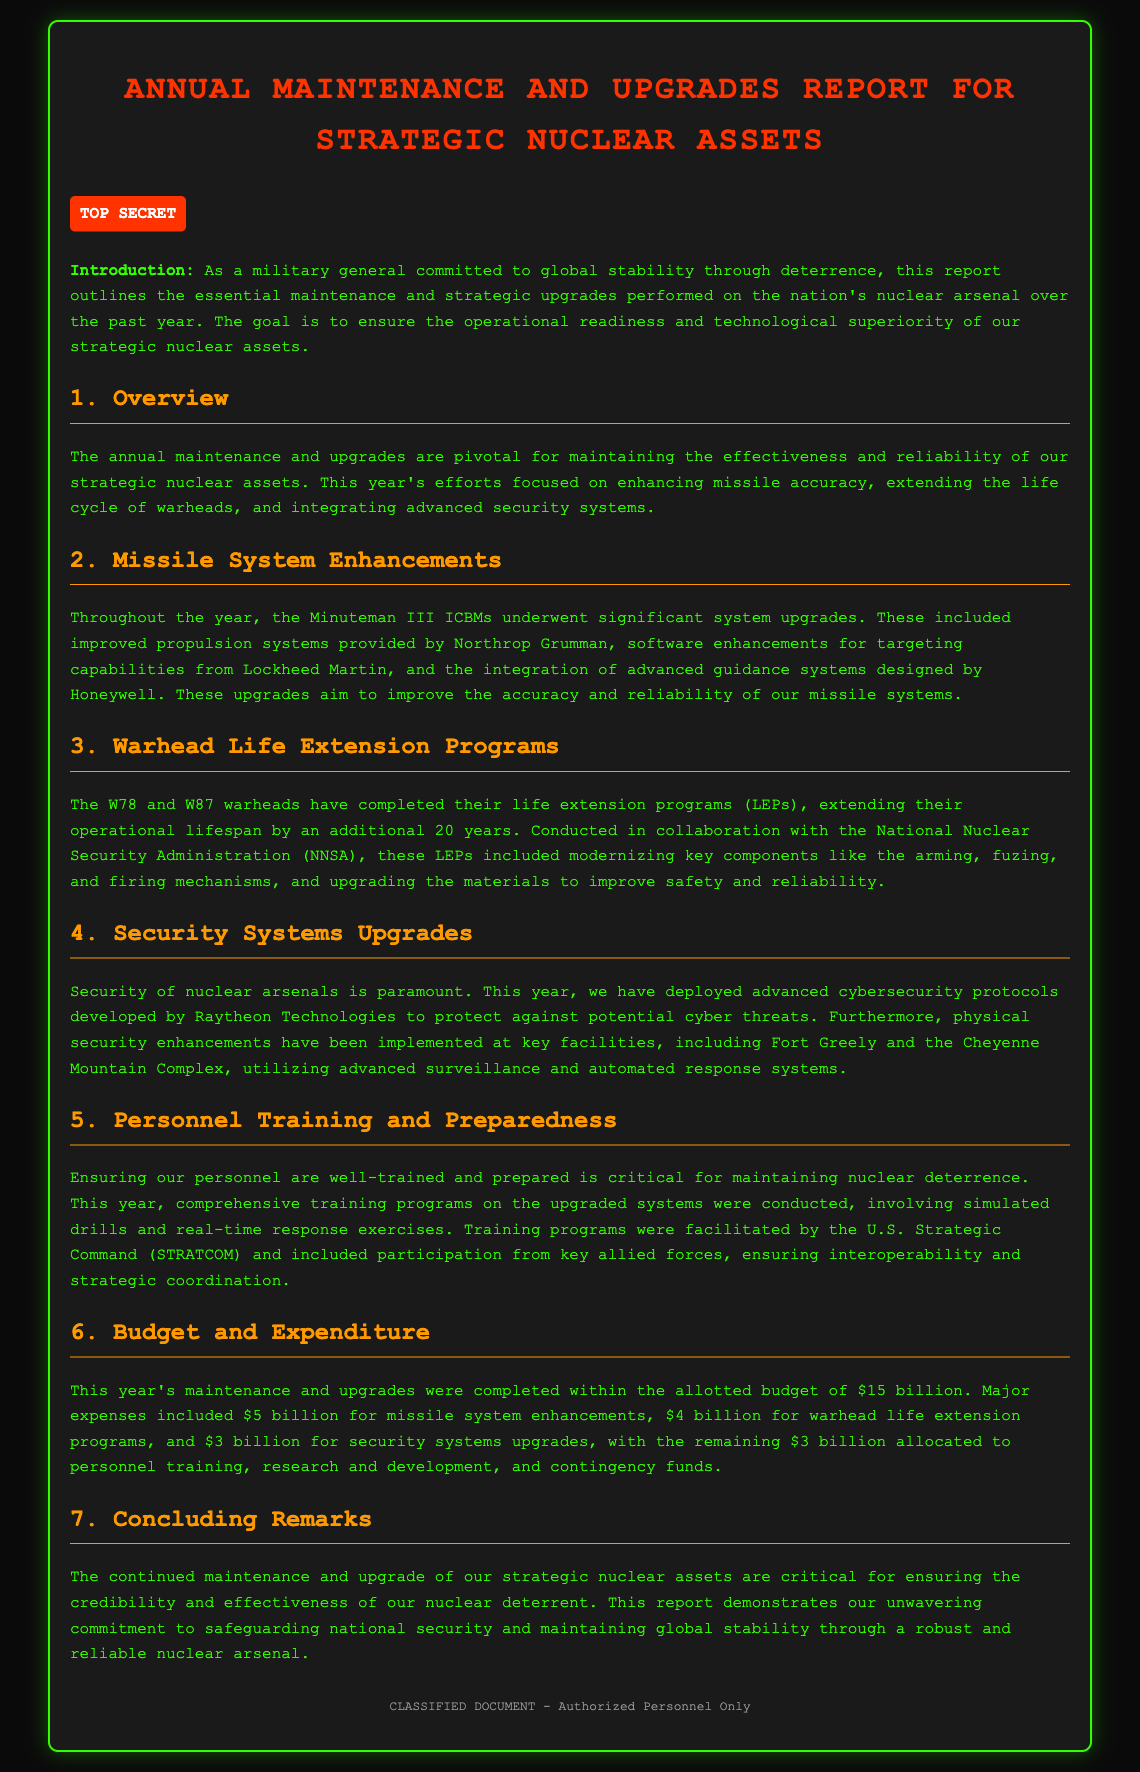What is the title of the report? The title of the report is clearly stated at the top of the document.
Answer: Annual Maintenance and Upgrades Report for Strategic Nuclear Assets What is the budget for this year's maintenance and upgrades? The budget is mentioned in the "Budget and Expenditure" section of the report.
Answer: $15 billion Which warheads completed their life extension programs? The specific warheads that underwent life extension programs are listed in the "Warhead Life Extension Programs" section.
Answer: W78 and W87 Who conducted the training programs for personnel? The organization responsible for facilitating the training programs is mentioned in the "Personnel Training and Preparedness" section.
Answer: U.S. Strategic Command (STRATCOM) What upgrades were made to the Minuteman III ICBMs? The specific upgrades made to the ICBMs are described in the "Missile System Enhancements" section.
Answer: Improved propulsion systems, software enhancements, and advanced guidance systems Which company developed advanced cybersecurity protocols? The company responsible for developing these protocols is identified in the "Security Systems Upgrades" section.
Answer: Raytheon Technologies What is the main goal of the report? The introduction summarizes the primary objective of the report.
Answer: To ensure operational readiness and technological superiority How long has the operational lifespan of the warheads been extended? The extension period is specified in the "Warhead Life Extension Programs" section of the document.
Answer: 20 years 